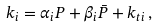<formula> <loc_0><loc_0><loc_500><loc_500>k _ { i } = \alpha _ { i } P + \beta _ { i } \bar { P } + k _ { t i } \, ,</formula> 